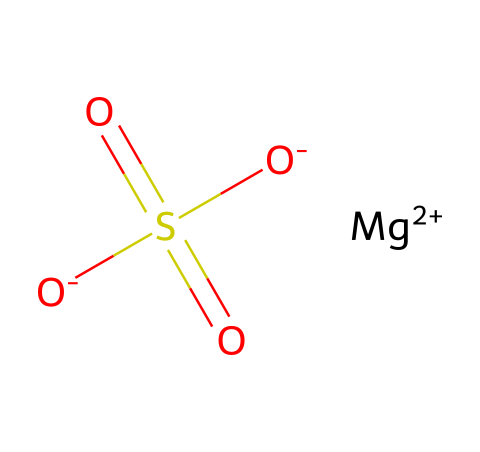What is the name of this chemical? The chemical structure corresponds to magnesium sulfate, which is commonly used in various applications, including as an electrolyte in bath salts.
Answer: magnesium sulfate How many oxygen atoms are in this molecule? By examining the structure, we can count the number of oxygen atoms present. There are four oxygen atoms in total, indicated by the four O symbols in the structure.
Answer: four What is the oxidation state of magnesium in this compound? The SMILES notation shows magnesium with a double positive charge, indicating that its oxidation state is +2 in magnesium sulfate.
Answer: +2 What type of ion does this compound contain? The presence of magnesium, indicated by the [Mg++] notation, signifies that this compound contains a cationic ion. Magnesium acts as a cation in this electrolyte.
Answer: cation Why is magnesium sulfate effective as an electrolyte? Magnesium sulfate dissociates into magnesium and sulfate ions when dissolved in water. This dissociation allows the solution to conduct electricity, characteristic of electrolytes.
Answer: electrical conductivity What role does sulfate play in this compound? The sulfate ion (SO4^2-) contributes to the overall charge balance of the compound and assists in the regulatory functions of various biological processes, making it significant in biological and therapeutic applications.
Answer: charge balance How is this compound commonly used in treatments? Magnesium sulfate is known for its muscle relaxant properties and is often used in bath salts to alleviate muscle tension and promote relaxation during baths.
Answer: muscle relaxant 